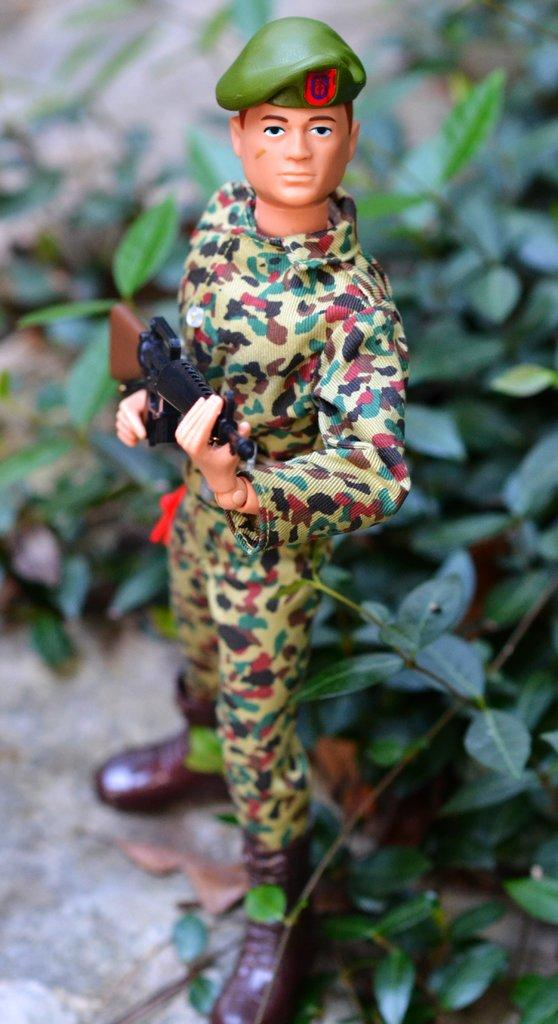What is the main subject of the image? There is a statue in the image. Can you describe the statue's appearance? The statue is of a person wearing a cap and holding a gun. What does the statue represent? The statue represents an army personnel. What can be seen in the background of the image? There are leaves in the background of the image. What time of day is depicted in the image? The provided facts do not mention the time of day, so it cannot be determined from the image. Can you describe the authority figure exchanging pleasantries with the statue? There is no authority figure or exchange of pleasantries depicted in the image; it only features a statue of an army personnel. 